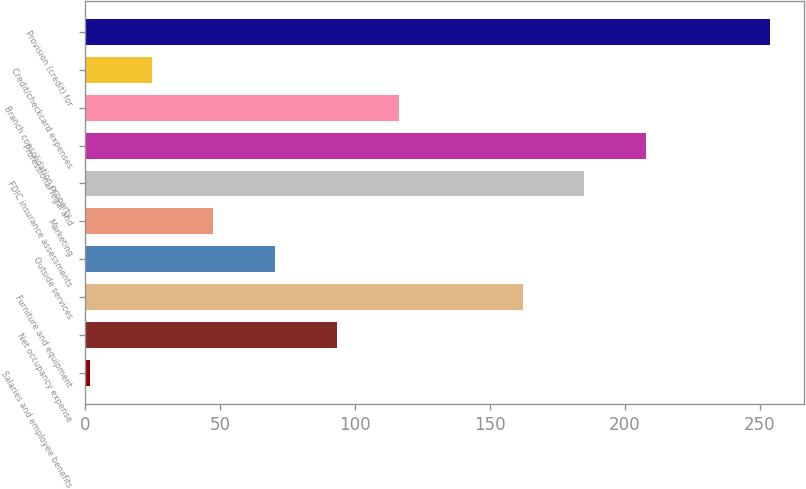<chart> <loc_0><loc_0><loc_500><loc_500><bar_chart><fcel>Salaries and employee benefits<fcel>Net occupancy expense<fcel>Furniture and equipment<fcel>Outside services<fcel>Marketing<fcel>FDIC insurance assessments<fcel>Professional legal and<fcel>Branch consolidation property<fcel>Credit/checkcard expenses<fcel>Provision (credit) for<nl><fcel>1.6<fcel>93.28<fcel>162.04<fcel>70.36<fcel>47.44<fcel>184.96<fcel>207.88<fcel>116.2<fcel>24.52<fcel>253.72<nl></chart> 